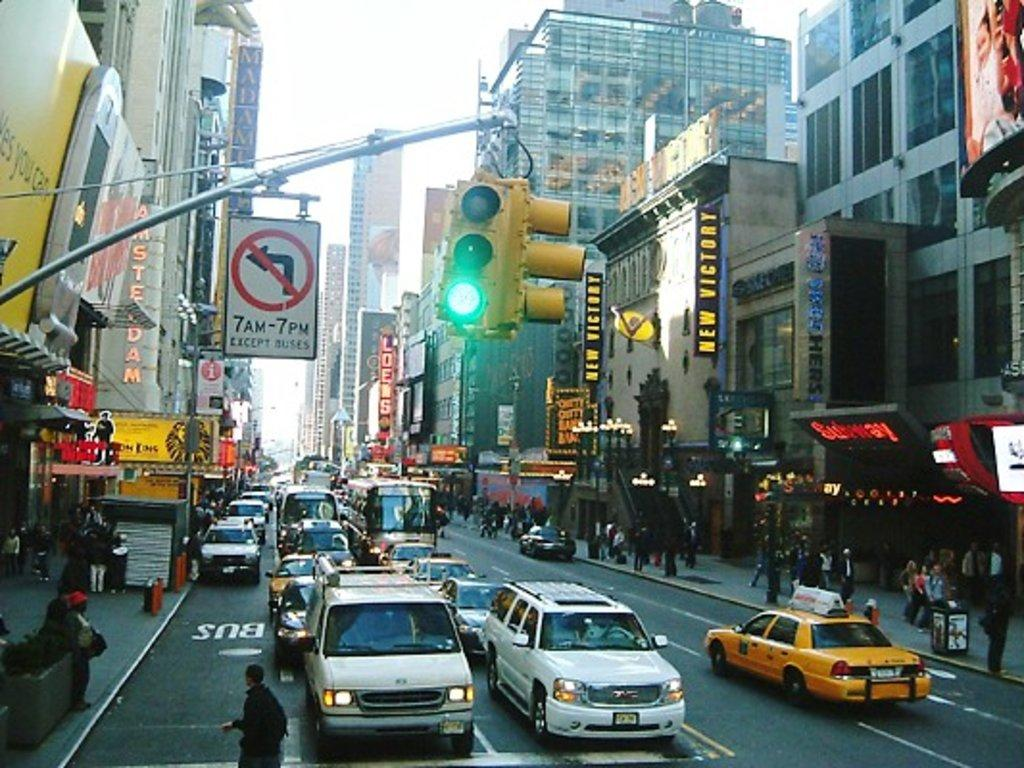Provide a one-sentence caption for the provided image. A busy street with many cars and people and a no left turn sign from 7 AM-7 PM. 